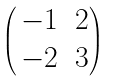<formula> <loc_0><loc_0><loc_500><loc_500>\begin{pmatrix} \, - 1 & 2 \\ \, - 2 & 3 \end{pmatrix}</formula> 